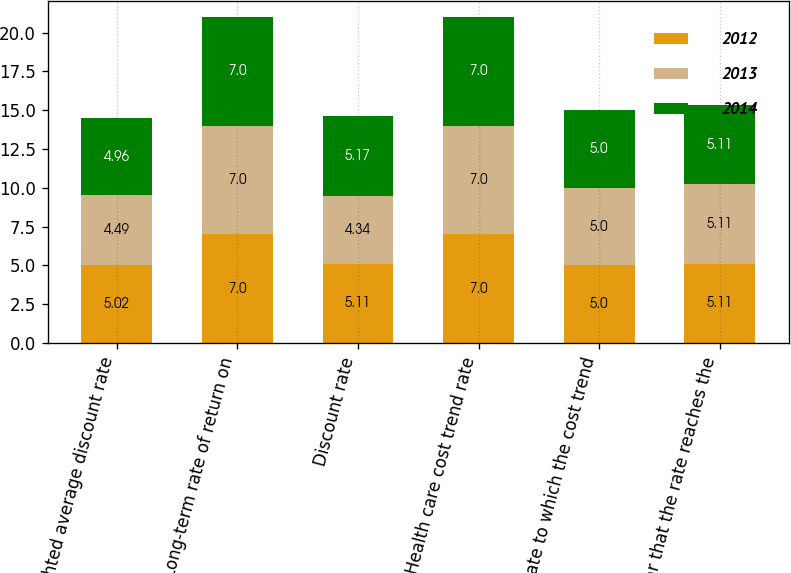Convert chart. <chart><loc_0><loc_0><loc_500><loc_500><stacked_bar_chart><ecel><fcel>Weighted average discount rate<fcel>Long-term rate of return on<fcel>Discount rate<fcel>Health care cost trend rate<fcel>Rate to which the cost trend<fcel>Year that the rate reaches the<nl><fcel>2012<fcel>5.02<fcel>7<fcel>5.11<fcel>7<fcel>5<fcel>5.11<nl><fcel>2013<fcel>4.49<fcel>7<fcel>4.34<fcel>7<fcel>5<fcel>5.11<nl><fcel>2014<fcel>4.96<fcel>7<fcel>5.17<fcel>7<fcel>5<fcel>5.11<nl></chart> 